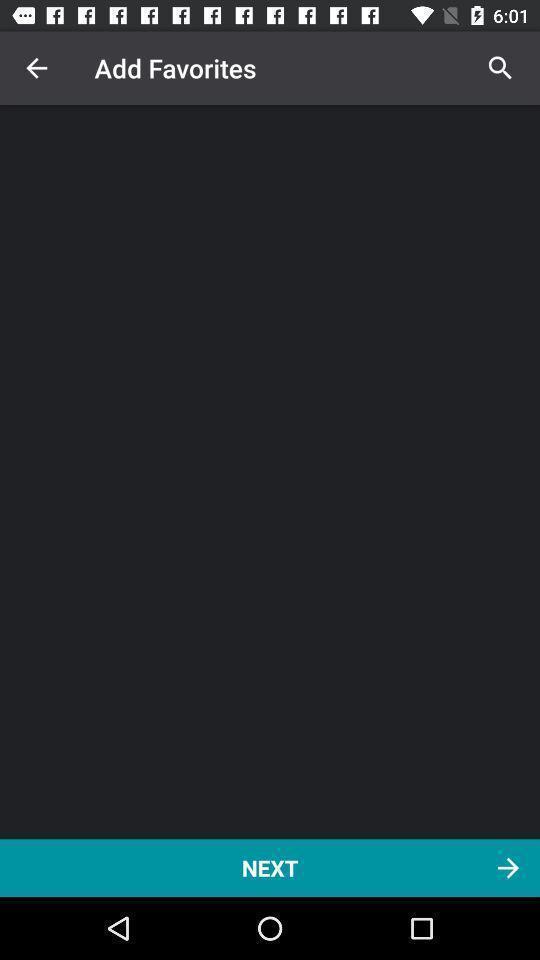Summarize the main components in this picture. Screen displaying movie streaming app. 